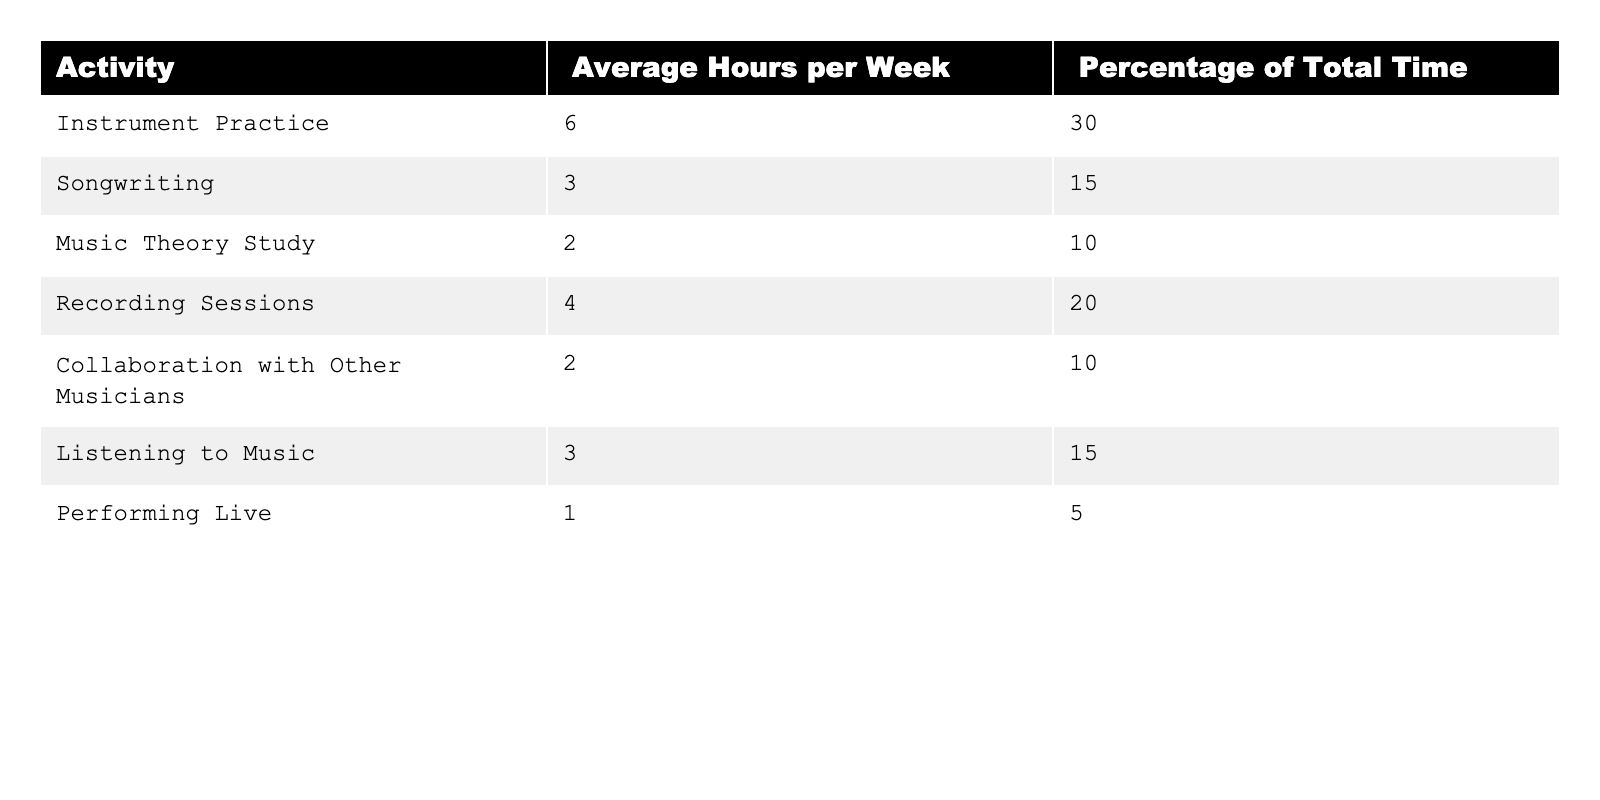What is the average number of hours per week spent on instrument practice? The table lists the average hours per week for each activity. For instrument practice, the value is directly given as 6 hours per week.
Answer: 6 hours What percentage of total time do amateur musicians spend on performing live? The table shows that the percentage of total time spent on performing live is listed as 5%.
Answer: 5% How many hours per week do amateur musicians spend on collaboration and listening to music combined? From the table, collaboration with other musicians averages 2 hours per week, and listening to music averages 3 hours per week. Adding these gives 2 + 3 = 5 hours per week combined.
Answer: 5 hours Which activity has the highest percentage of total time spent, and what is that percentage? The table indicates that instrument practice has the highest percentage of total time spent at 30%.
Answer: Instrument practice, 30% If an amateur musician spends 12 hours on musical activities in total, how much of that time is allocated to songwriting and music theory study? Songwriting is 3 hours, and music theory study is 2 hours. Adding these (3 + 2) gives 5 hours in total for both activities. The percentage of 12 hours allocated would be (5/12) * 100 = approximately 41.67%.
Answer: 41.67% of total time What is the total average number of hours spent on songwriting, music theory study, and collaboration? Songwriting averages 3 hours, music theory study averages 2 hours, and collaboration averages 2 hours. Summing these gives 3 + 2 + 2 = 7 hours per week.
Answer: 7 hours Does the average time spent on recording sessions exceed the time spent on performing live? The table shows that average hours for recording sessions is 4, while performing live is 1. Thus, 4 > 1, confirming that recording sessions exceed performing live.
Answer: Yes What is the total percentage of time spent on all activities except for performing live? The percentage for performing live is 5%. To find the total for all activities except this, we subtract 5 from 100, yielding 100 - 5 = 95%.
Answer: 95% If an amateur musician practices the guitar for one hour less than the average and spends the average on all other activities, how many total hours do they spend? The average for instrument practice is 6 hours, so one hour less is 5 hours. Adding all activities gives: 5 + 3 + 2 + 4 + 2 + 3 + 1 = 20 hours total.
Answer: 20 hours What is the ratio of hours spent on listening to music compared to music theory study? Listening to music averages 3 hours, music theory study averages 2 hours. The ratio of 3 to 2 can be expressed as 3:2.
Answer: 3:2 